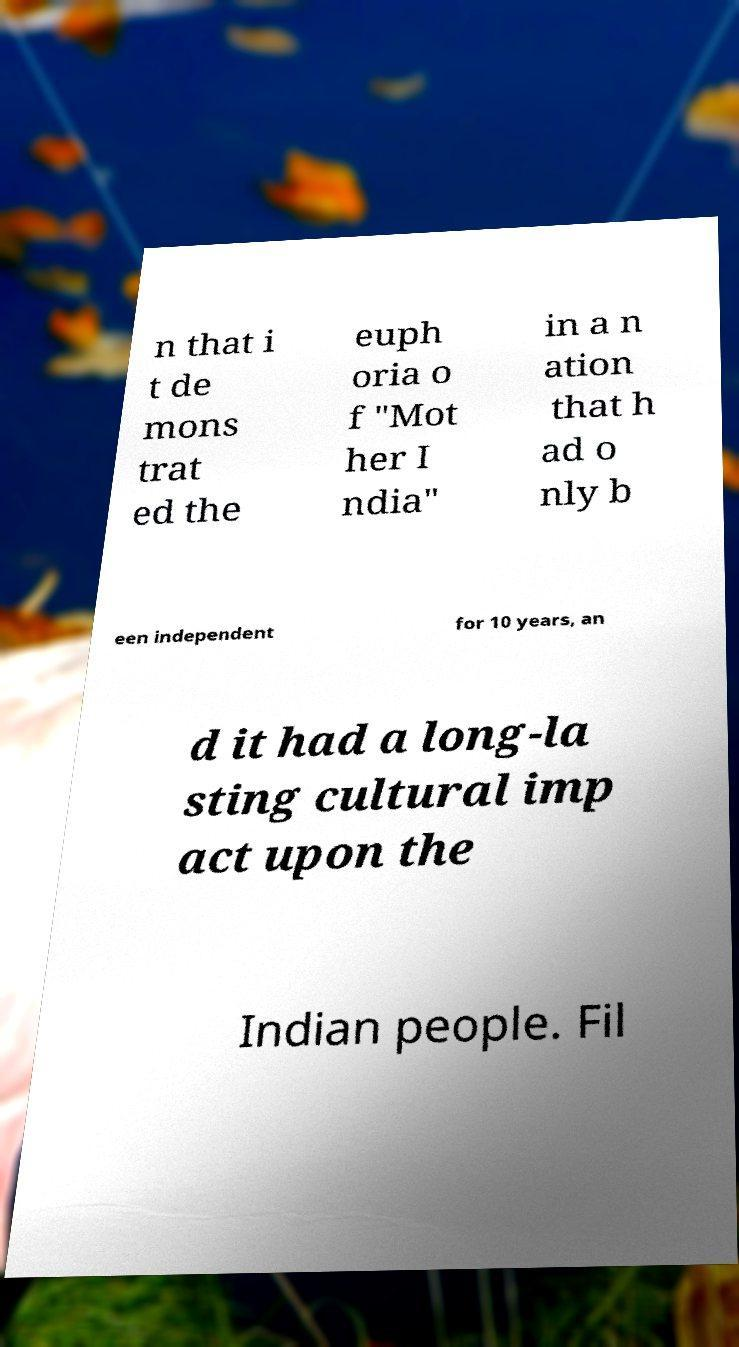Can you accurately transcribe the text from the provided image for me? n that i t de mons trat ed the euph oria o f "Mot her I ndia" in a n ation that h ad o nly b een independent for 10 years, an d it had a long-la sting cultural imp act upon the Indian people. Fil 